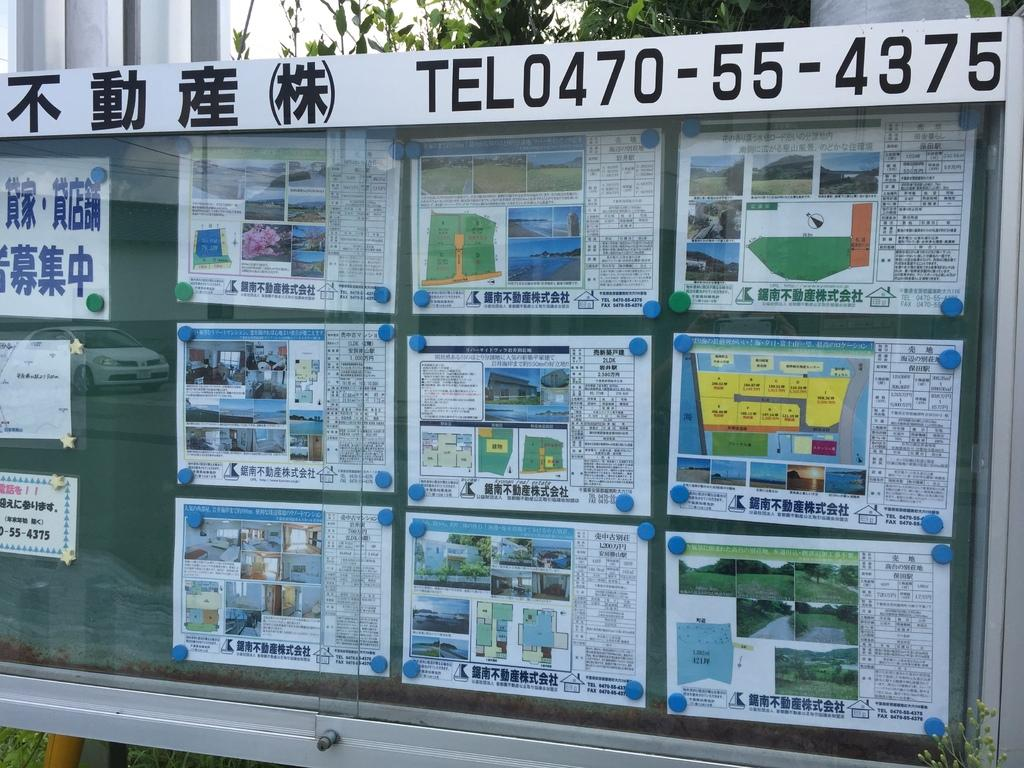<image>
Relay a brief, clear account of the picture shown. An Asian poster board with various maps and photos with the title TEL0470-55-4375. 